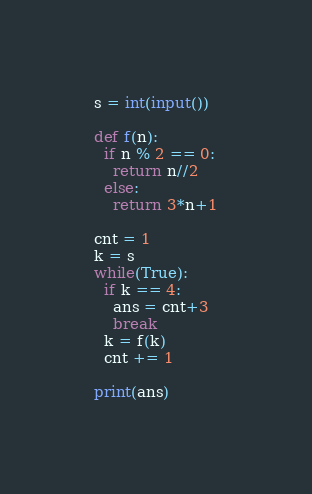<code> <loc_0><loc_0><loc_500><loc_500><_Python_>s = int(input())

def f(n):
  if n % 2 == 0:
    return n//2
  else:
    return 3*n+1

cnt = 1
k = s
while(True):
  if k == 4:
    ans = cnt+3
    break
  k = f(k)
  cnt += 1

print(ans)</code> 